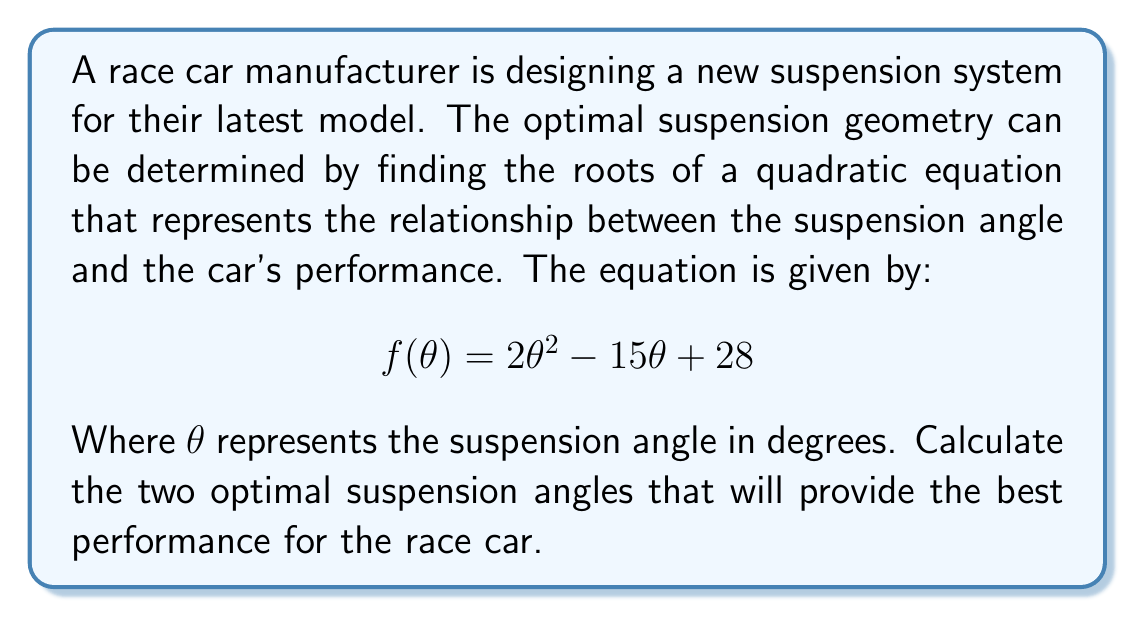Could you help me with this problem? To find the optimal suspension angles, we need to determine the roots of the quadratic equation. We can use the quadratic formula:

$$\theta = \frac{-b \pm \sqrt{b^2 - 4ac}}{2a}$$

Where $a = 2$, $b = -15$, and $c = 28$.

Step 1: Calculate the discriminant
$$\begin{align}
b^2 - 4ac &= (-15)^2 - 4(2)(28) \\
&= 225 - 224 \\
&= 1
\end{align}$$

Step 2: Apply the quadratic formula
$$\begin{align}
\theta &= \frac{-(-15) \pm \sqrt{1}}{2(2)} \\
&= \frac{15 \pm 1}{4}
\end{align}$$

Step 3: Calculate the two roots
$$\begin{align}
\theta_1 &= \frac{15 + 1}{4} = \frac{16}{4} = 4 \\
\theta_2 &= \frac{15 - 1}{4} = \frac{14}{4} = 3.5
\end{align}$$

Therefore, the two optimal suspension angles are 4 degrees and 3.5 degrees.
Answer: The optimal suspension angles are 4 degrees and 3.5 degrees. 